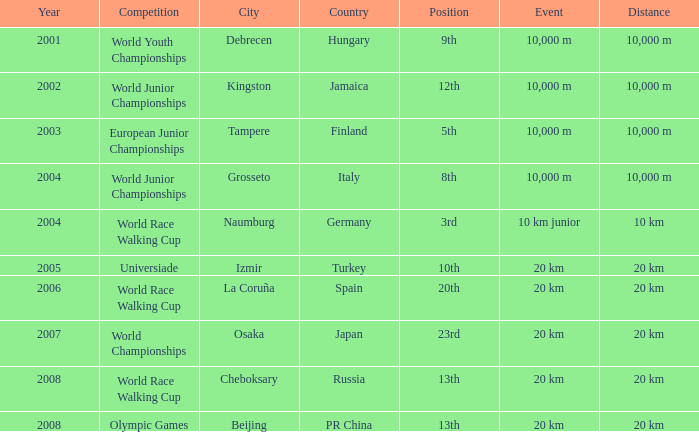Can you parse all the data within this table? {'header': ['Year', 'Competition', 'City', 'Country', 'Position', 'Event', 'Distance'], 'rows': [['2001', 'World Youth Championships', 'Debrecen', 'Hungary', '9th', '10,000 m', '10,000 m'], ['2002', 'World Junior Championships', 'Kingston', 'Jamaica', '12th', '10,000 m', '10,000 m'], ['2003', 'European Junior Championships', 'Tampere', 'Finland', '5th', '10,000 m', '10,000 m'], ['2004', 'World Junior Championships', 'Grosseto', 'Italy', '8th', '10,000 m', '10,000 m'], ['2004', 'World Race Walking Cup', 'Naumburg', 'Germany', '3rd', '10 km junior', '10 km'], ['2005', 'Universiade', 'Izmir', 'Turkey', '10th', '20 km', '20 km'], ['2006', 'World Race Walking Cup', 'La Coruña', 'Spain', '20th', '20 km', '20 km'], ['2007', 'World Championships', 'Osaka', 'Japan', '23rd', '20 km', '20 km'], ['2008', 'World Race Walking Cup', 'Cheboksary', 'Russia', '13th', '20 km', '20 km'], ['2008', 'Olympic Games', 'Beijing', 'PR China', '13th', '20 km', '20 km']]} What were the notes when his position was 10th? 20 km. 